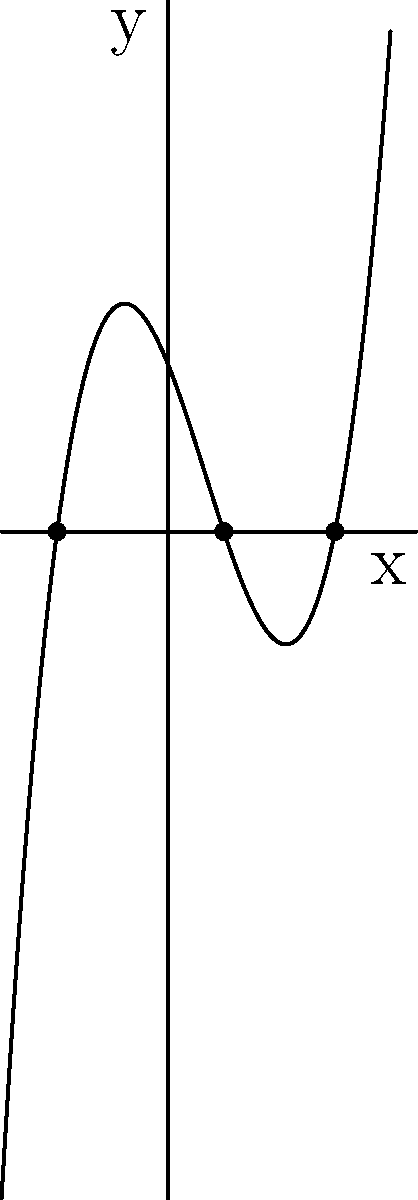In our community WhatsApp group, we're discussing local gardening trends. A member shared a graph representing the growth rate of a new plant species introduced in Vanderburgh County parks. The graph resembles a cubic function. How many real roots does this function have, and what do they represent in terms of the plant's growth rate? Let's analyze the graph step-by-step:

1) The graph represents a cubic function, as it has the characteristic S-shape of a cubic polynomial.

2) We can see that the curve intersects the x-axis at three distinct points. These points are the roots of the function.

3) The roots can be approximated from the graph as:
   - $x = -2$
   - $x = 1$
   - $x = 3$

4) In the context of plant growth rate:
   - The negative root ($x = -2$) doesn't have a practical interpretation in this scenario.
   - The root at $x = 1$ represents a point where the growth rate is zero, possibly indicating a transition point in the plant's life cycle.
   - The root at $x = 3$ represents another point where the growth rate is zero, possibly indicating maturity or the end of a growth phase.

5) The function has three real roots because it crosses the x-axis three times.

In the context of plant growth, the positive roots could represent times (in weeks or months) when the plant's growth rate is zero, potentially indicating important stages in its development.
Answer: 3 real roots; represent points of zero growth rate 